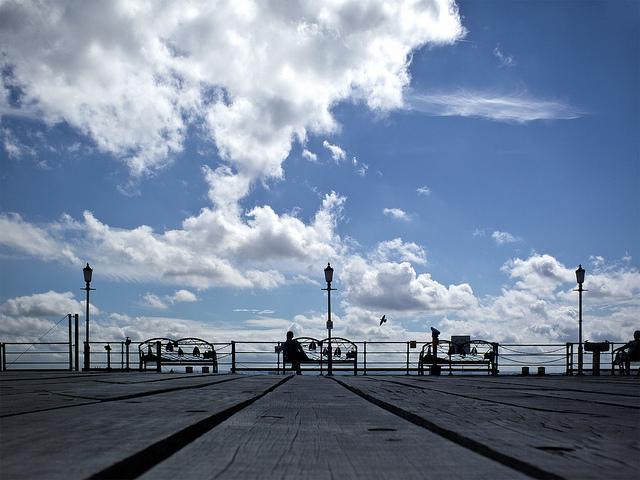How many people are sitting in benches?
Give a very brief answer. 2. How many light post?
Give a very brief answer. 3. How many cars have a surfboard on the roof?
Give a very brief answer. 0. 